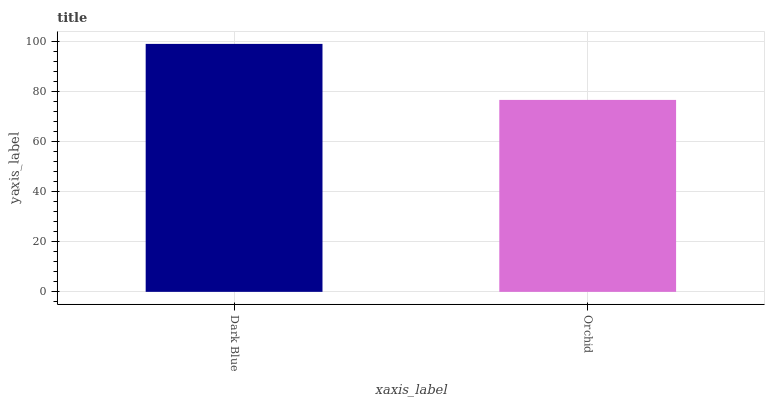Is Orchid the minimum?
Answer yes or no. Yes. Is Dark Blue the maximum?
Answer yes or no. Yes. Is Orchid the maximum?
Answer yes or no. No. Is Dark Blue greater than Orchid?
Answer yes or no. Yes. Is Orchid less than Dark Blue?
Answer yes or no. Yes. Is Orchid greater than Dark Blue?
Answer yes or no. No. Is Dark Blue less than Orchid?
Answer yes or no. No. Is Dark Blue the high median?
Answer yes or no. Yes. Is Orchid the low median?
Answer yes or no. Yes. Is Orchid the high median?
Answer yes or no. No. Is Dark Blue the low median?
Answer yes or no. No. 